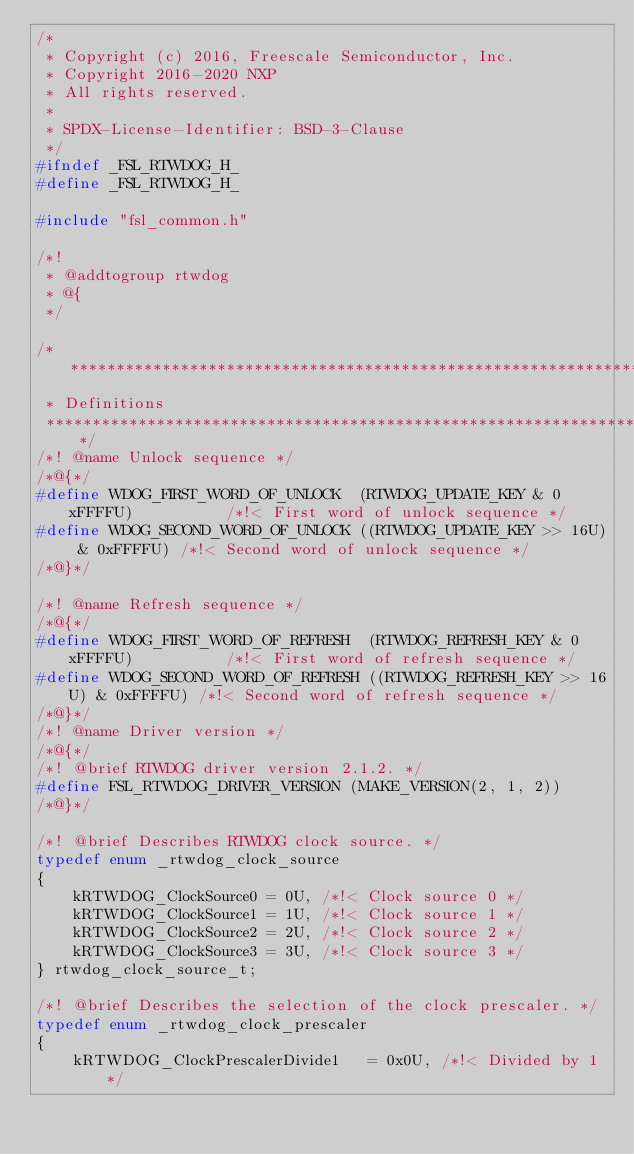<code> <loc_0><loc_0><loc_500><loc_500><_C_>/*
 * Copyright (c) 2016, Freescale Semiconductor, Inc.
 * Copyright 2016-2020 NXP
 * All rights reserved.
 *
 * SPDX-License-Identifier: BSD-3-Clause
 */
#ifndef _FSL_RTWDOG_H_
#define _FSL_RTWDOG_H_

#include "fsl_common.h"

/*!
 * @addtogroup rtwdog
 * @{
 */

/*******************************************************************************
 * Definitions
 *******************************************************************************/
/*! @name Unlock sequence */
/*@{*/
#define WDOG_FIRST_WORD_OF_UNLOCK  (RTWDOG_UPDATE_KEY & 0xFFFFU)          /*!< First word of unlock sequence */
#define WDOG_SECOND_WORD_OF_UNLOCK ((RTWDOG_UPDATE_KEY >> 16U) & 0xFFFFU) /*!< Second word of unlock sequence */
/*@}*/

/*! @name Refresh sequence */
/*@{*/
#define WDOG_FIRST_WORD_OF_REFRESH  (RTWDOG_REFRESH_KEY & 0xFFFFU)          /*!< First word of refresh sequence */
#define WDOG_SECOND_WORD_OF_REFRESH ((RTWDOG_REFRESH_KEY >> 16U) & 0xFFFFU) /*!< Second word of refresh sequence */
/*@}*/
/*! @name Driver version */
/*@{*/
/*! @brief RTWDOG driver version 2.1.2. */
#define FSL_RTWDOG_DRIVER_VERSION (MAKE_VERSION(2, 1, 2))
/*@}*/

/*! @brief Describes RTWDOG clock source. */
typedef enum _rtwdog_clock_source
{
    kRTWDOG_ClockSource0 = 0U, /*!< Clock source 0 */
    kRTWDOG_ClockSource1 = 1U, /*!< Clock source 1 */
    kRTWDOG_ClockSource2 = 2U, /*!< Clock source 2 */
    kRTWDOG_ClockSource3 = 3U, /*!< Clock source 3 */
} rtwdog_clock_source_t;

/*! @brief Describes the selection of the clock prescaler. */
typedef enum _rtwdog_clock_prescaler
{
    kRTWDOG_ClockPrescalerDivide1   = 0x0U, /*!< Divided by 1 */</code> 